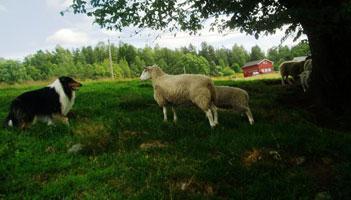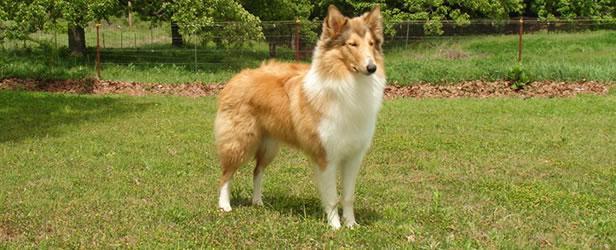The first image is the image on the left, the second image is the image on the right. Considering the images on both sides, is "An image features a person standing in front of a plank fence and behind multiple sheep, with a dog nearby." valid? Answer yes or no. No. The first image is the image on the left, the second image is the image on the right. Considering the images on both sides, is "The right image contains a dog chasing sheep towards the right." valid? Answer yes or no. No. 